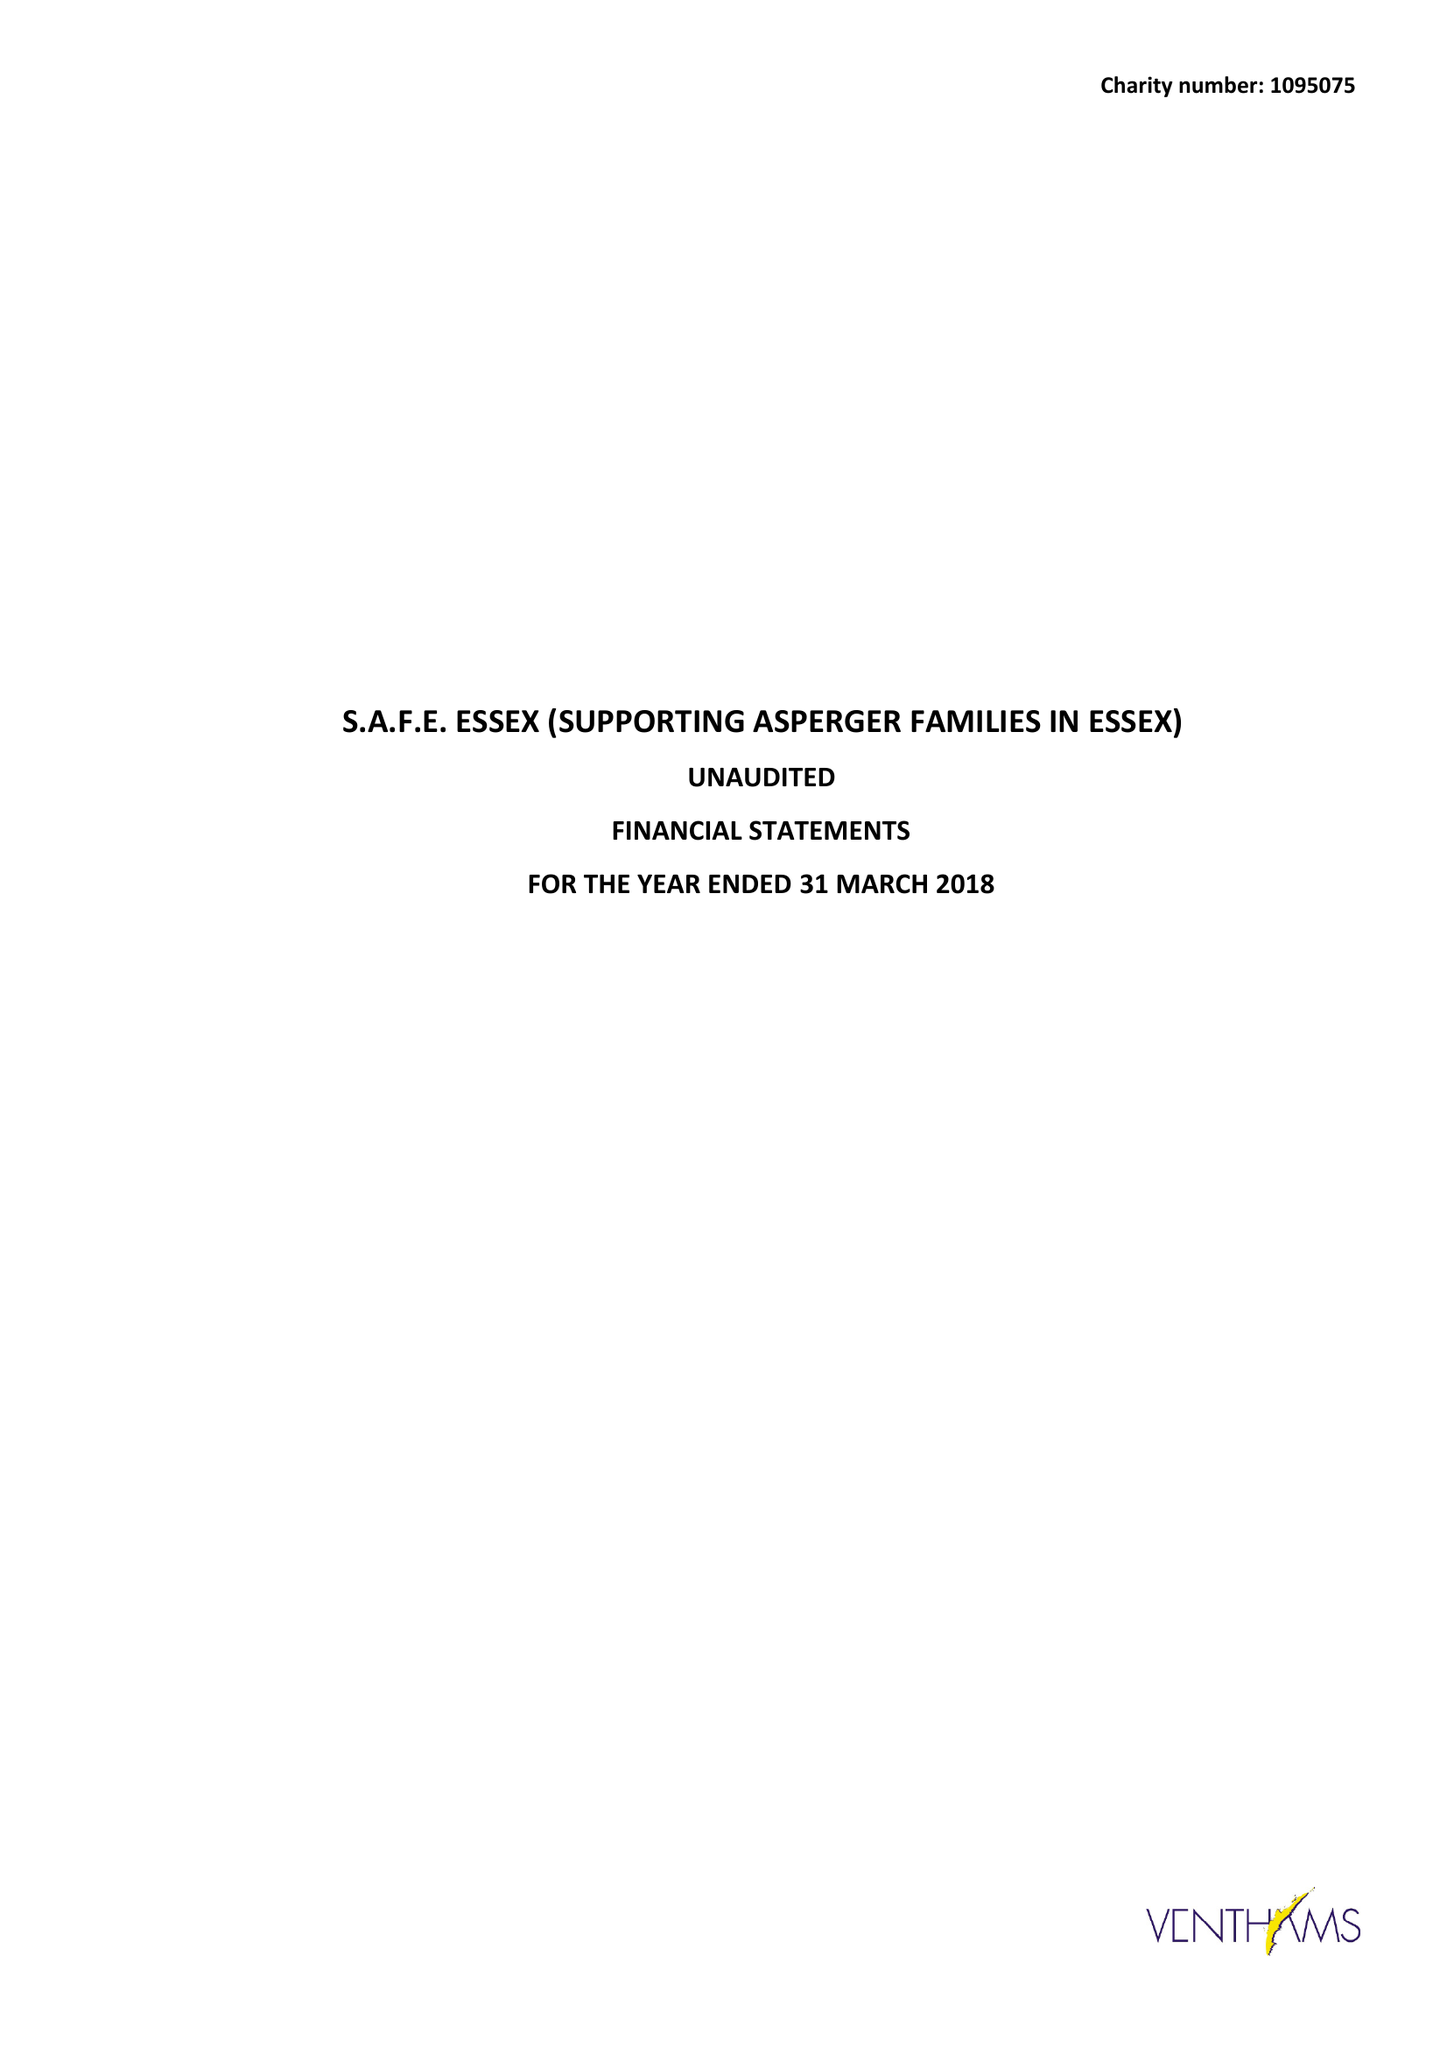What is the value for the report_date?
Answer the question using a single word or phrase. 2018-03-31 